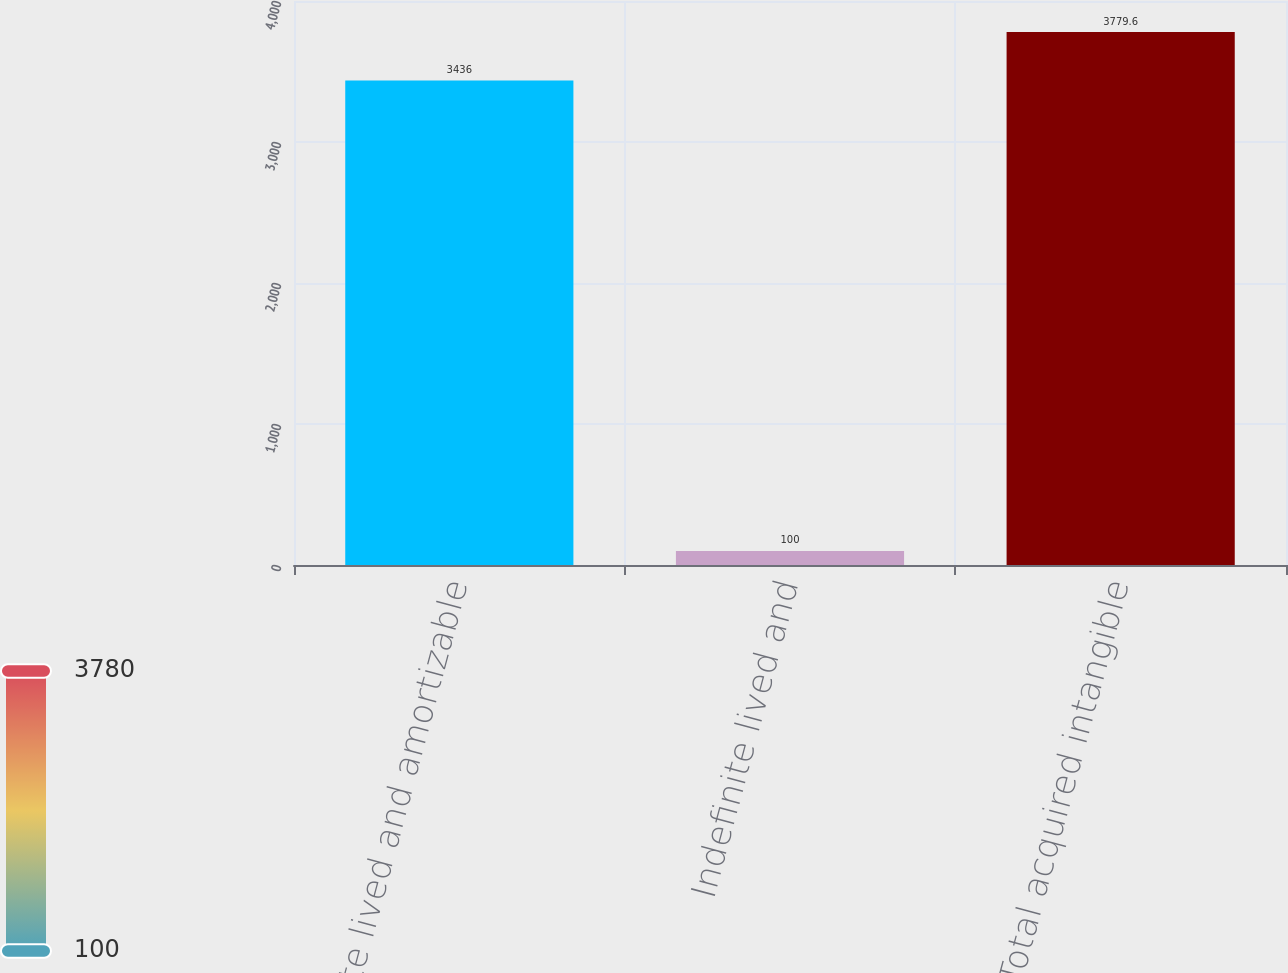<chart> <loc_0><loc_0><loc_500><loc_500><bar_chart><fcel>Definite lived and amortizable<fcel>Indefinite lived and<fcel>Total acquired intangible<nl><fcel>3436<fcel>100<fcel>3779.6<nl></chart> 